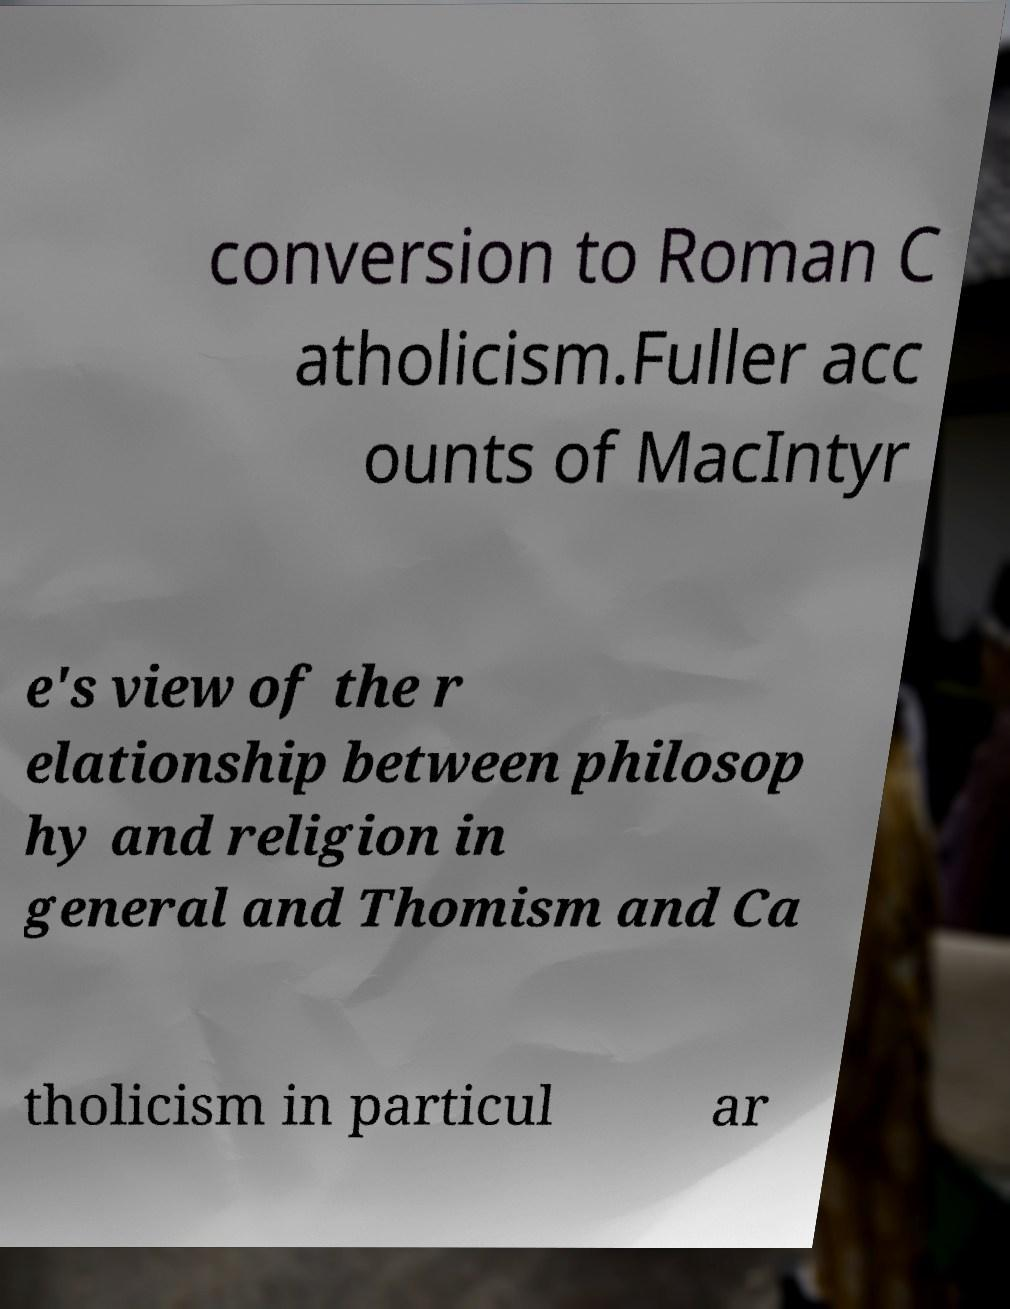For documentation purposes, I need the text within this image transcribed. Could you provide that? conversion to Roman C atholicism.Fuller acc ounts of MacIntyr e's view of the r elationship between philosop hy and religion in general and Thomism and Ca tholicism in particul ar 